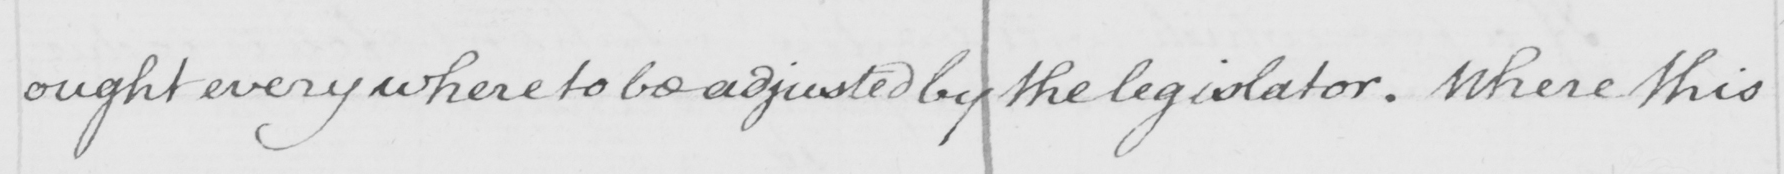Transcribe the text shown in this historical manuscript line. ought every where to be adjusted by the legislator . Where this 